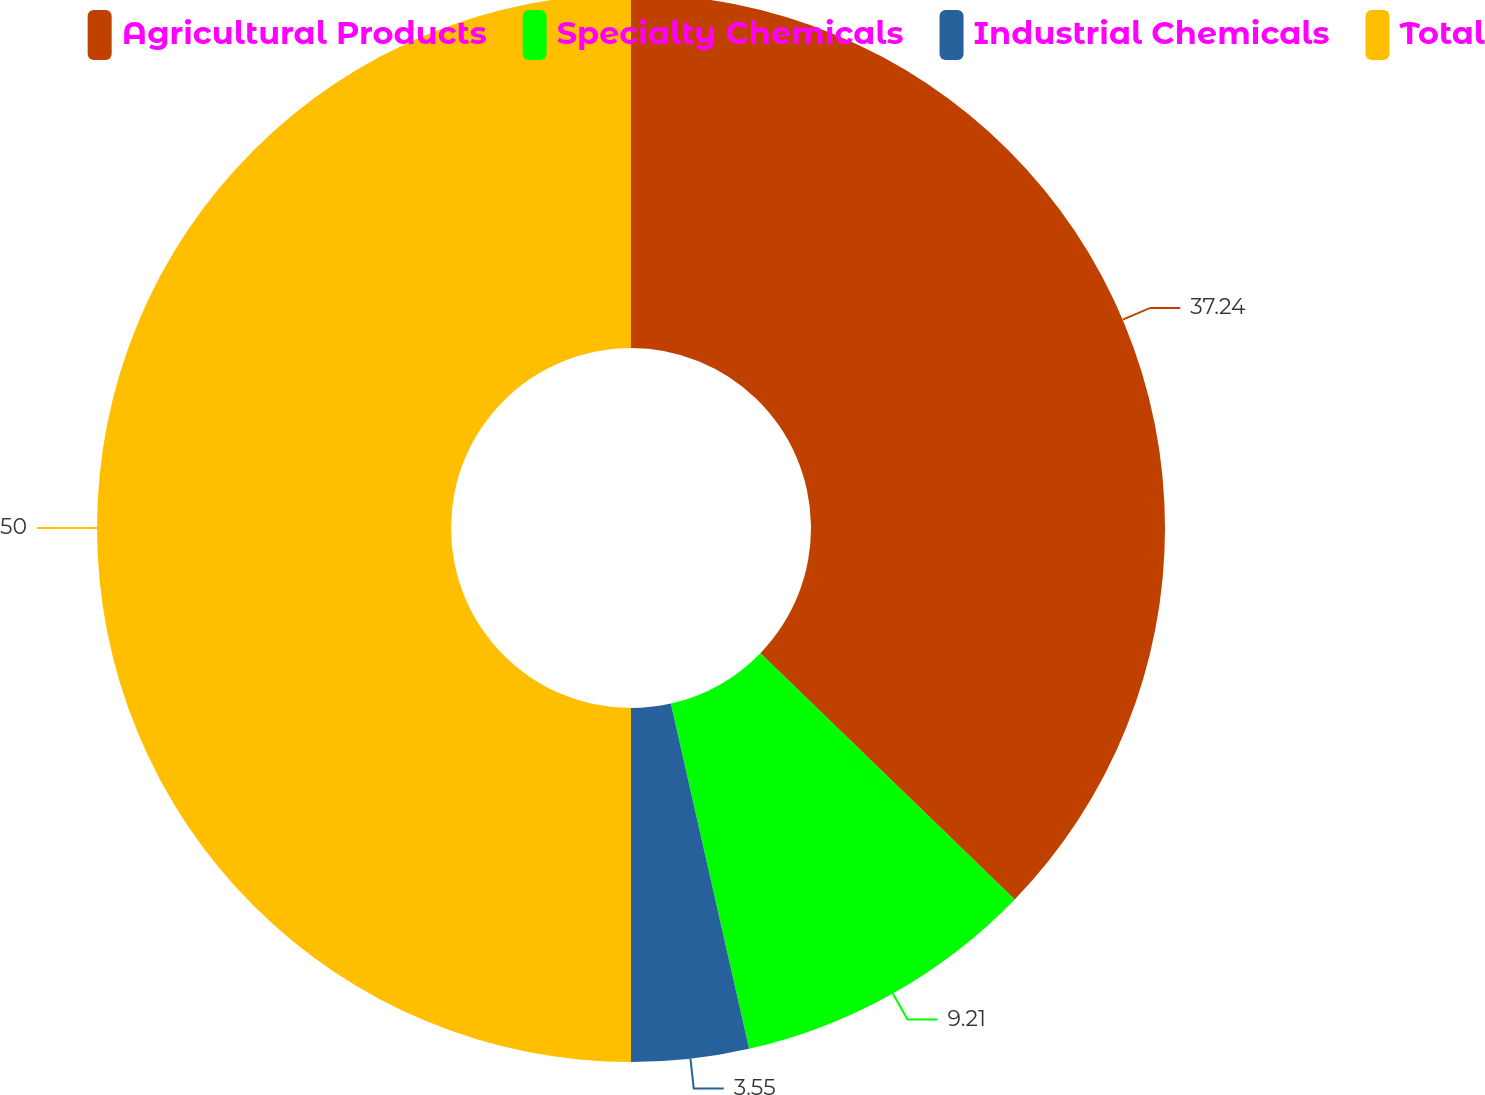<chart> <loc_0><loc_0><loc_500><loc_500><pie_chart><fcel>Agricultural Products<fcel>Specialty Chemicals<fcel>Industrial Chemicals<fcel>Total<nl><fcel>37.24%<fcel>9.21%<fcel>3.55%<fcel>50.0%<nl></chart> 